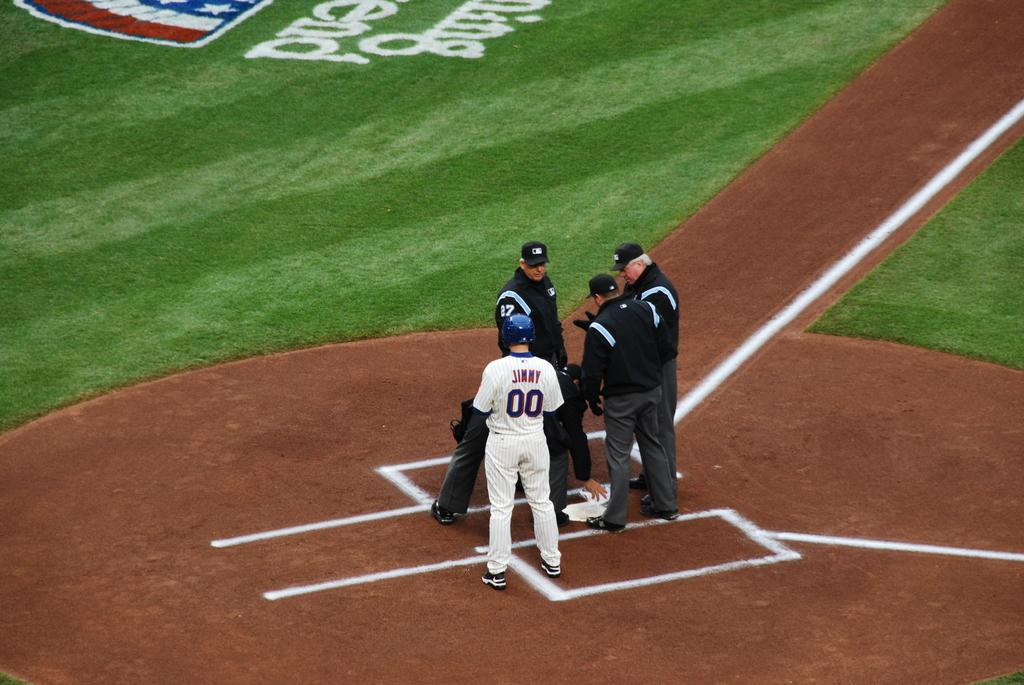Provide a one-sentence caption for the provided image. A baseball player named Jimmy wears number 00. 